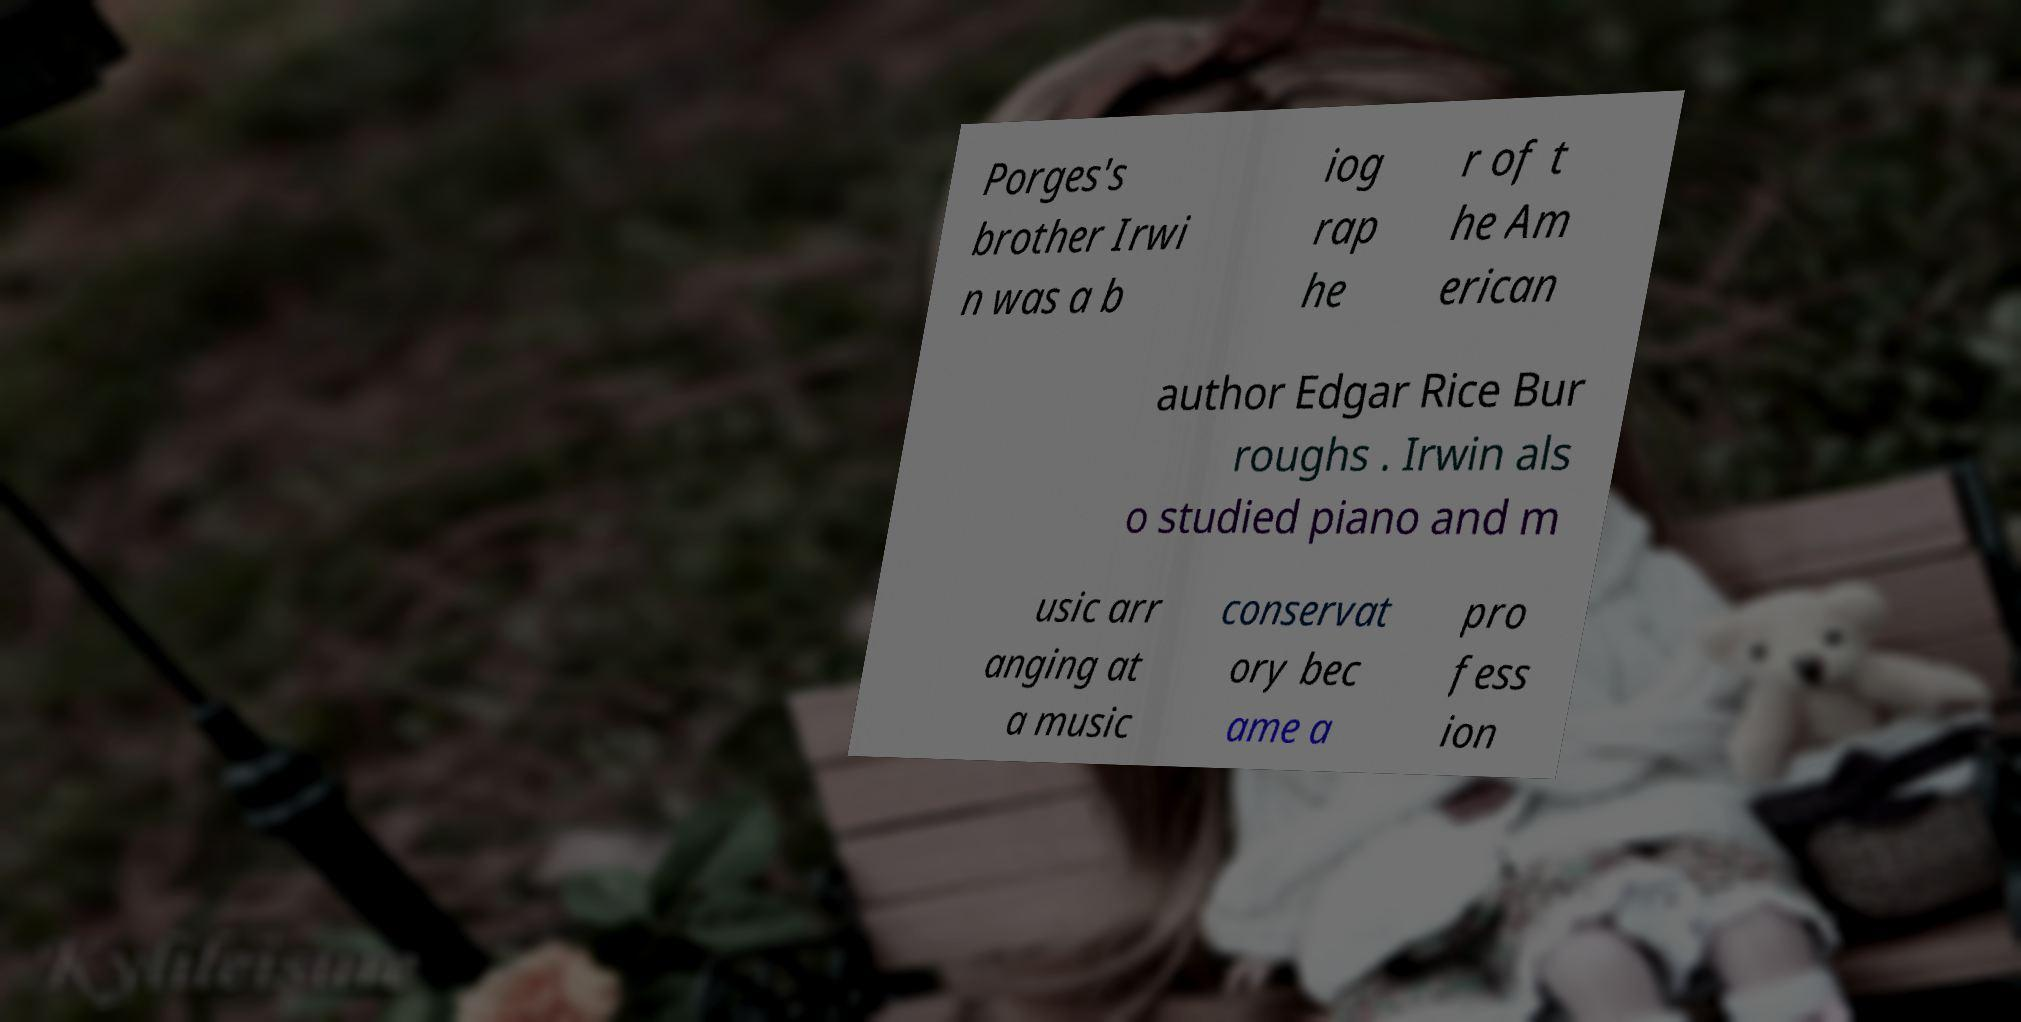There's text embedded in this image that I need extracted. Can you transcribe it verbatim? Porges's brother Irwi n was a b iog rap he r of t he Am erican author Edgar Rice Bur roughs . Irwin als o studied piano and m usic arr anging at a music conservat ory bec ame a pro fess ion 